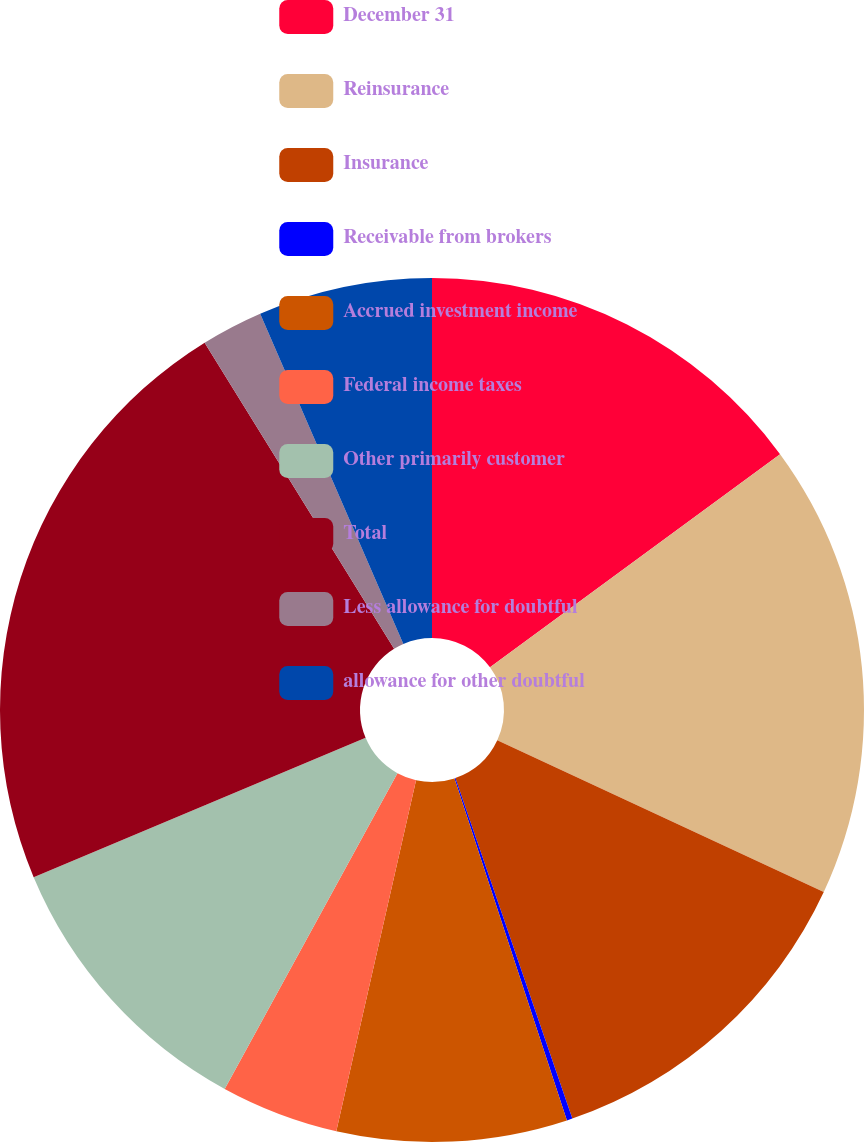<chart> <loc_0><loc_0><loc_500><loc_500><pie_chart><fcel>December 31<fcel>Reinsurance<fcel>Insurance<fcel>Receivable from brokers<fcel>Accrued investment income<fcel>Federal income taxes<fcel>Other primarily customer<fcel>Total<fcel>Less allowance for doubtful<fcel>allowance for other doubtful<nl><fcel>14.91%<fcel>17.01%<fcel>12.81%<fcel>0.21%<fcel>8.61%<fcel>4.41%<fcel>10.71%<fcel>22.5%<fcel>2.31%<fcel>6.51%<nl></chart> 